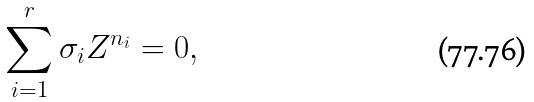<formula> <loc_0><loc_0><loc_500><loc_500>\sum _ { i = 1 } ^ { r } \sigma _ { i } Z ^ { n _ { i } } = 0 ,</formula> 